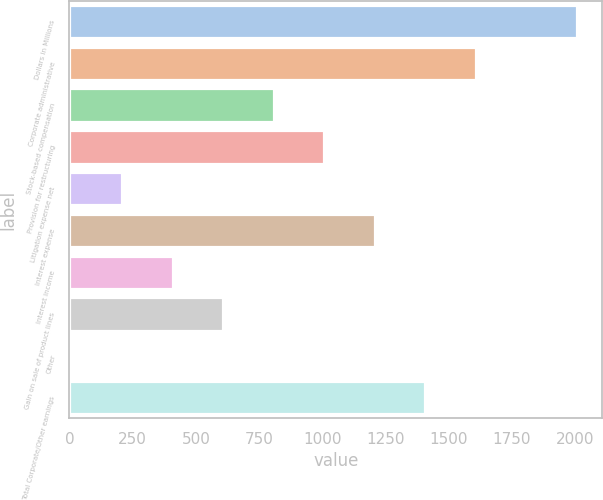Convert chart to OTSL. <chart><loc_0><loc_0><loc_500><loc_500><bar_chart><fcel>Dollars in Millions<fcel>Corporate administrative<fcel>Stock-based compensation<fcel>Provision for restructuring<fcel>Litigation expense net<fcel>Interest expense<fcel>Interest income<fcel>Gain on sale of product lines<fcel>Other<fcel>Total Corporate/Other earnings<nl><fcel>2008<fcel>1608.2<fcel>808.6<fcel>1008.5<fcel>208.9<fcel>1208.4<fcel>408.8<fcel>608.7<fcel>9<fcel>1408.3<nl></chart> 